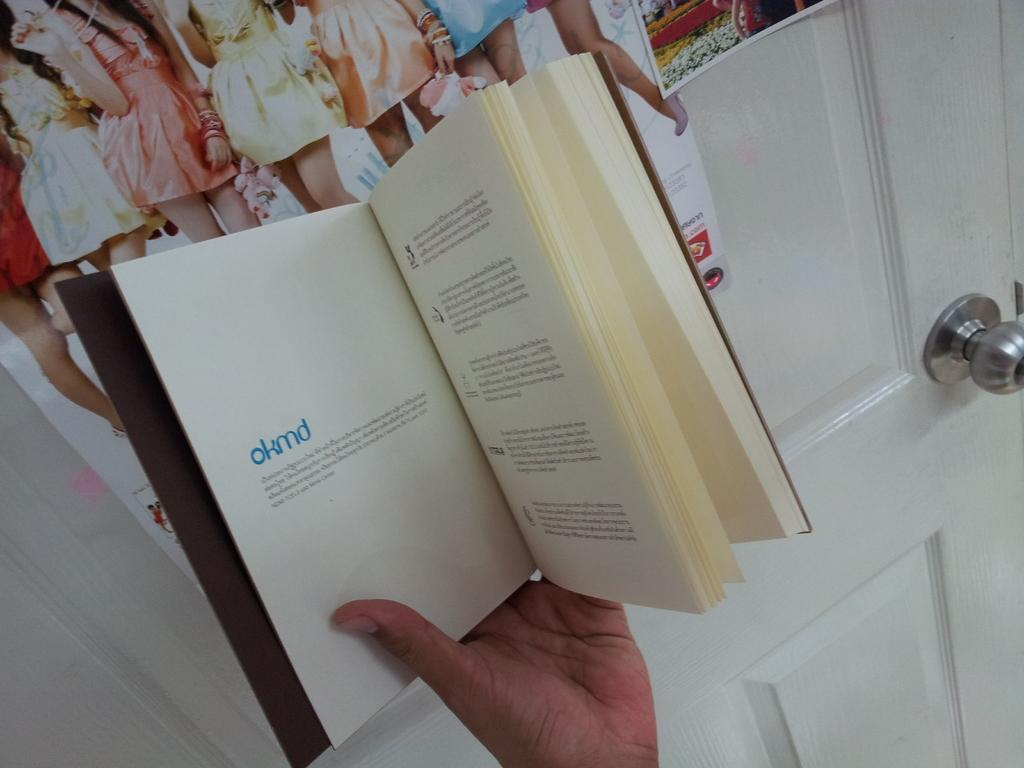<image>
Render a clear and concise summary of the photo. A book is opened to the first page which says okmd. 